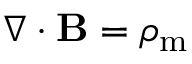<formula> <loc_0><loc_0><loc_500><loc_500>\nabla \cdot B = \rho _ { m }</formula> 